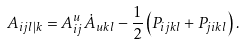<formula> <loc_0><loc_0><loc_500><loc_500>A _ { i j l | k } = A _ { i j } ^ { u } \dot { A } _ { u k l } - \frac { 1 } { 2 } \left ( P _ { i j k l } + P _ { j i k l } \right ) .</formula> 